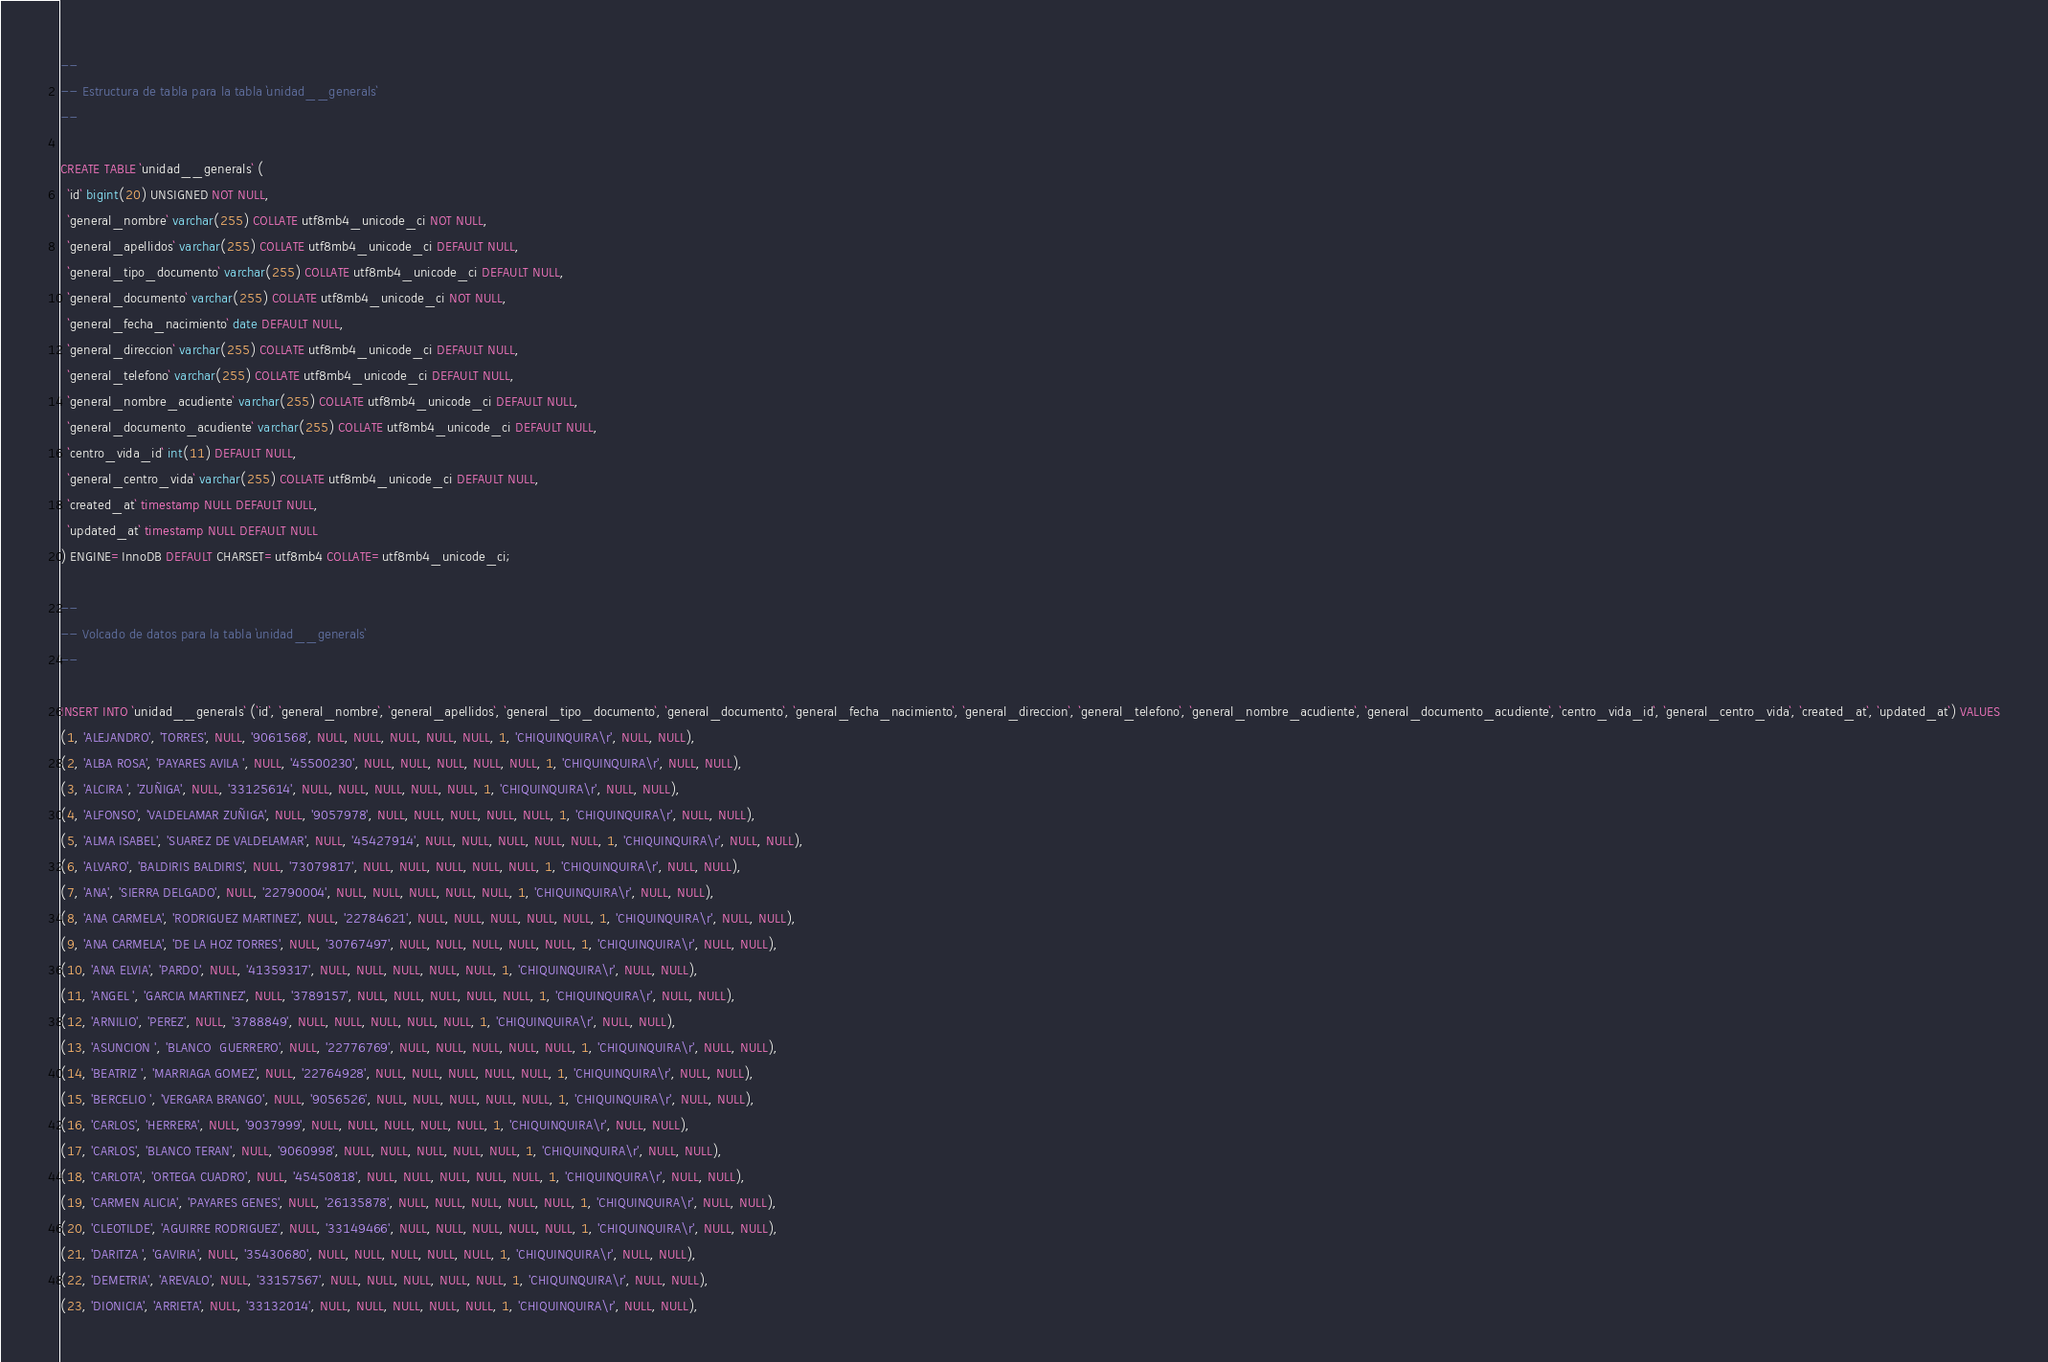Convert code to text. <code><loc_0><loc_0><loc_500><loc_500><_SQL_>--
-- Estructura de tabla para la tabla `unidad__generals`
--

CREATE TABLE `unidad__generals` (
  `id` bigint(20) UNSIGNED NOT NULL,
  `general_nombre` varchar(255) COLLATE utf8mb4_unicode_ci NOT NULL,
  `general_apellidos` varchar(255) COLLATE utf8mb4_unicode_ci DEFAULT NULL,
  `general_tipo_documento` varchar(255) COLLATE utf8mb4_unicode_ci DEFAULT NULL,
  `general_documento` varchar(255) COLLATE utf8mb4_unicode_ci NOT NULL,
  `general_fecha_nacimiento` date DEFAULT NULL,
  `general_direccion` varchar(255) COLLATE utf8mb4_unicode_ci DEFAULT NULL,
  `general_telefono` varchar(255) COLLATE utf8mb4_unicode_ci DEFAULT NULL,
  `general_nombre_acudiente` varchar(255) COLLATE utf8mb4_unicode_ci DEFAULT NULL,
  `general_documento_acudiente` varchar(255) COLLATE utf8mb4_unicode_ci DEFAULT NULL,
  `centro_vida_id` int(11) DEFAULT NULL,
  `general_centro_vida` varchar(255) COLLATE utf8mb4_unicode_ci DEFAULT NULL,
  `created_at` timestamp NULL DEFAULT NULL,
  `updated_at` timestamp NULL DEFAULT NULL
) ENGINE=InnoDB DEFAULT CHARSET=utf8mb4 COLLATE=utf8mb4_unicode_ci;

--
-- Volcado de datos para la tabla `unidad__generals`
--

INSERT INTO `unidad__generals` (`id`, `general_nombre`, `general_apellidos`, `general_tipo_documento`, `general_documento`, `general_fecha_nacimiento`, `general_direccion`, `general_telefono`, `general_nombre_acudiente`, `general_documento_acudiente`, `centro_vida_id`, `general_centro_vida`, `created_at`, `updated_at`) VALUES
(1, 'ALEJANDRO', 'TORRES', NULL, '9061568', NULL, NULL, NULL, NULL, NULL, 1, 'CHIQUINQUIRA\r', NULL, NULL),
(2, 'ALBA ROSA', 'PAYARES AVILA ', NULL, '45500230', NULL, NULL, NULL, NULL, NULL, 1, 'CHIQUINQUIRA\r', NULL, NULL),
(3, 'ALCIRA ', 'ZUÑIGA', NULL, '33125614', NULL, NULL, NULL, NULL, NULL, 1, 'CHIQUINQUIRA\r', NULL, NULL),
(4, 'ALFONSO', 'VALDELAMAR ZUÑIGA', NULL, '9057978', NULL, NULL, NULL, NULL, NULL, 1, 'CHIQUINQUIRA\r', NULL, NULL),
(5, 'ALMA ISABEL', 'SUAREZ DE VALDELAMAR', NULL, '45427914', NULL, NULL, NULL, NULL, NULL, 1, 'CHIQUINQUIRA\r', NULL, NULL),
(6, 'ALVARO', 'BALDIRIS BALDIRIS', NULL, '73079817', NULL, NULL, NULL, NULL, NULL, 1, 'CHIQUINQUIRA\r', NULL, NULL),
(7, 'ANA', 'SIERRA DELGADO', NULL, '22790004', NULL, NULL, NULL, NULL, NULL, 1, 'CHIQUINQUIRA\r', NULL, NULL),
(8, 'ANA CARMELA', 'RODRIGUEZ MARTINEZ', NULL, '22784621', NULL, NULL, NULL, NULL, NULL, 1, 'CHIQUINQUIRA\r', NULL, NULL),
(9, 'ANA CARMELA', 'DE LA HOZ TORRES', NULL, '30767497', NULL, NULL, NULL, NULL, NULL, 1, 'CHIQUINQUIRA\r', NULL, NULL),
(10, 'ANA ELVIA', 'PARDO', NULL, '41359317', NULL, NULL, NULL, NULL, NULL, 1, 'CHIQUINQUIRA\r', NULL, NULL),
(11, 'ANGEL ', 'GARCIA MARTINEZ', NULL, '3789157', NULL, NULL, NULL, NULL, NULL, 1, 'CHIQUINQUIRA\r', NULL, NULL),
(12, 'ARNILIO', 'PEREZ', NULL, '3788849', NULL, NULL, NULL, NULL, NULL, 1, 'CHIQUINQUIRA\r', NULL, NULL),
(13, 'ASUNCION ', 'BLANCO  GUERRERO', NULL, '22776769', NULL, NULL, NULL, NULL, NULL, 1, 'CHIQUINQUIRA\r', NULL, NULL),
(14, 'BEATRIZ ', 'MARRIAGA GOMEZ', NULL, '22764928', NULL, NULL, NULL, NULL, NULL, 1, 'CHIQUINQUIRA\r', NULL, NULL),
(15, 'BERCELIO ', 'VERGARA BRANGO', NULL, '9056526', NULL, NULL, NULL, NULL, NULL, 1, 'CHIQUINQUIRA\r', NULL, NULL),
(16, 'CARLOS', 'HERRERA', NULL, '9037999', NULL, NULL, NULL, NULL, NULL, 1, 'CHIQUINQUIRA\r', NULL, NULL),
(17, 'CARLOS', 'BLANCO TERAN', NULL, '9060998', NULL, NULL, NULL, NULL, NULL, 1, 'CHIQUINQUIRA\r', NULL, NULL),
(18, 'CARLOTA', 'ORTEGA CUADRO', NULL, '45450818', NULL, NULL, NULL, NULL, NULL, 1, 'CHIQUINQUIRA\r', NULL, NULL),
(19, 'CARMEN ALICIA', 'PAYARES GENES', NULL, '26135878', NULL, NULL, NULL, NULL, NULL, 1, 'CHIQUINQUIRA\r', NULL, NULL),
(20, 'CLEOTILDE', 'AGUIRRE RODRIGUEZ', NULL, '33149466', NULL, NULL, NULL, NULL, NULL, 1, 'CHIQUINQUIRA\r', NULL, NULL),
(21, 'DARITZA ', 'GAVIRIA', NULL, '35430680', NULL, NULL, NULL, NULL, NULL, 1, 'CHIQUINQUIRA\r', NULL, NULL),
(22, 'DEMETRIA', 'AREVALO', NULL, '33157567', NULL, NULL, NULL, NULL, NULL, 1, 'CHIQUINQUIRA\r', NULL, NULL),
(23, 'DIONICIA', 'ARRIETA', NULL, '33132014', NULL, NULL, NULL, NULL, NULL, 1, 'CHIQUINQUIRA\r', NULL, NULL),</code> 